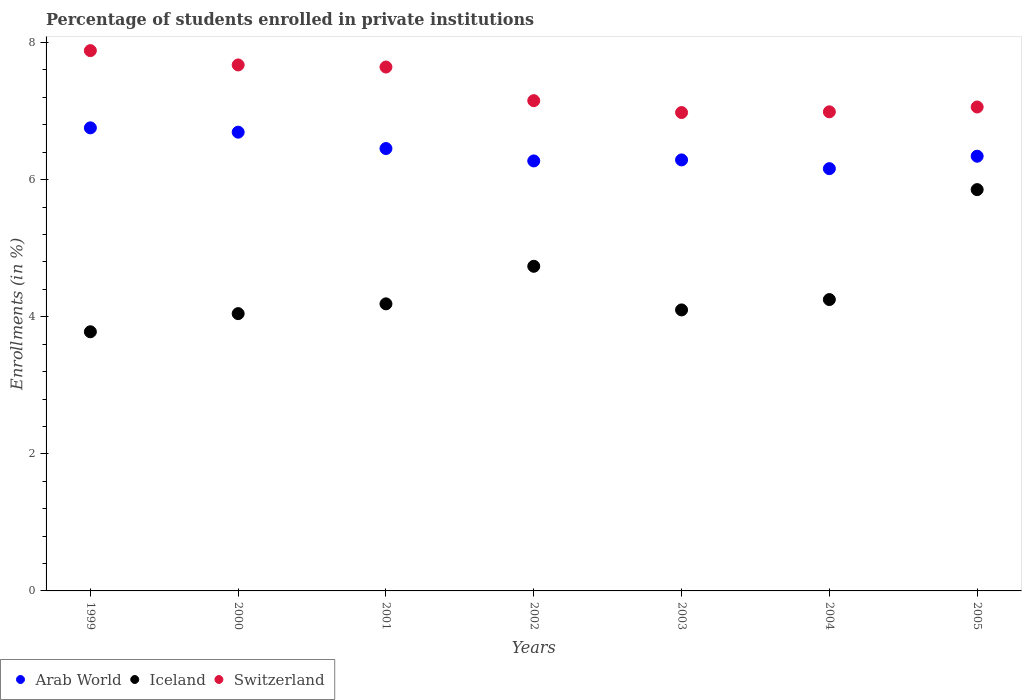How many different coloured dotlines are there?
Your answer should be compact. 3. What is the percentage of trained teachers in Switzerland in 2005?
Offer a very short reply. 7.06. Across all years, what is the maximum percentage of trained teachers in Switzerland?
Provide a succinct answer. 7.88. Across all years, what is the minimum percentage of trained teachers in Arab World?
Your answer should be compact. 6.16. In which year was the percentage of trained teachers in Switzerland maximum?
Offer a very short reply. 1999. What is the total percentage of trained teachers in Iceland in the graph?
Your response must be concise. 30.96. What is the difference between the percentage of trained teachers in Iceland in 1999 and that in 2005?
Your answer should be compact. -2.07. What is the difference between the percentage of trained teachers in Iceland in 2004 and the percentage of trained teachers in Switzerland in 2005?
Provide a short and direct response. -2.81. What is the average percentage of trained teachers in Iceland per year?
Offer a very short reply. 4.42. In the year 1999, what is the difference between the percentage of trained teachers in Switzerland and percentage of trained teachers in Iceland?
Your answer should be very brief. 4.1. What is the ratio of the percentage of trained teachers in Iceland in 1999 to that in 2000?
Make the answer very short. 0.93. Is the percentage of trained teachers in Switzerland in 1999 less than that in 2000?
Your answer should be very brief. No. What is the difference between the highest and the second highest percentage of trained teachers in Switzerland?
Make the answer very short. 0.21. What is the difference between the highest and the lowest percentage of trained teachers in Switzerland?
Provide a short and direct response. 0.9. Is the sum of the percentage of trained teachers in Switzerland in 2001 and 2002 greater than the maximum percentage of trained teachers in Arab World across all years?
Provide a succinct answer. Yes. Does the percentage of trained teachers in Switzerland monotonically increase over the years?
Your response must be concise. No. Is the percentage of trained teachers in Switzerland strictly greater than the percentage of trained teachers in Iceland over the years?
Offer a terse response. Yes. What is the difference between two consecutive major ticks on the Y-axis?
Offer a very short reply. 2. What is the title of the graph?
Make the answer very short. Percentage of students enrolled in private institutions. What is the label or title of the X-axis?
Your answer should be compact. Years. What is the label or title of the Y-axis?
Keep it short and to the point. Enrollments (in %). What is the Enrollments (in %) of Arab World in 1999?
Your response must be concise. 6.76. What is the Enrollments (in %) of Iceland in 1999?
Your answer should be compact. 3.78. What is the Enrollments (in %) in Switzerland in 1999?
Provide a succinct answer. 7.88. What is the Enrollments (in %) of Arab World in 2000?
Offer a very short reply. 6.69. What is the Enrollments (in %) of Iceland in 2000?
Provide a short and direct response. 4.05. What is the Enrollments (in %) of Switzerland in 2000?
Your answer should be very brief. 7.67. What is the Enrollments (in %) in Arab World in 2001?
Your response must be concise. 6.45. What is the Enrollments (in %) in Iceland in 2001?
Provide a succinct answer. 4.19. What is the Enrollments (in %) of Switzerland in 2001?
Your answer should be compact. 7.64. What is the Enrollments (in %) of Arab World in 2002?
Ensure brevity in your answer.  6.27. What is the Enrollments (in %) in Iceland in 2002?
Make the answer very short. 4.74. What is the Enrollments (in %) of Switzerland in 2002?
Offer a terse response. 7.15. What is the Enrollments (in %) in Arab World in 2003?
Your answer should be compact. 6.29. What is the Enrollments (in %) in Iceland in 2003?
Your answer should be very brief. 4.1. What is the Enrollments (in %) in Switzerland in 2003?
Your answer should be very brief. 6.98. What is the Enrollments (in %) in Arab World in 2004?
Offer a very short reply. 6.16. What is the Enrollments (in %) in Iceland in 2004?
Make the answer very short. 4.25. What is the Enrollments (in %) of Switzerland in 2004?
Offer a terse response. 6.99. What is the Enrollments (in %) in Arab World in 2005?
Make the answer very short. 6.34. What is the Enrollments (in %) of Iceland in 2005?
Give a very brief answer. 5.85. What is the Enrollments (in %) in Switzerland in 2005?
Offer a very short reply. 7.06. Across all years, what is the maximum Enrollments (in %) of Arab World?
Offer a terse response. 6.76. Across all years, what is the maximum Enrollments (in %) of Iceland?
Provide a succinct answer. 5.85. Across all years, what is the maximum Enrollments (in %) of Switzerland?
Provide a short and direct response. 7.88. Across all years, what is the minimum Enrollments (in %) of Arab World?
Offer a very short reply. 6.16. Across all years, what is the minimum Enrollments (in %) in Iceland?
Your answer should be compact. 3.78. Across all years, what is the minimum Enrollments (in %) of Switzerland?
Make the answer very short. 6.98. What is the total Enrollments (in %) of Arab World in the graph?
Provide a short and direct response. 44.97. What is the total Enrollments (in %) of Iceland in the graph?
Ensure brevity in your answer.  30.96. What is the total Enrollments (in %) of Switzerland in the graph?
Offer a very short reply. 51.38. What is the difference between the Enrollments (in %) in Arab World in 1999 and that in 2000?
Ensure brevity in your answer.  0.06. What is the difference between the Enrollments (in %) of Iceland in 1999 and that in 2000?
Your response must be concise. -0.26. What is the difference between the Enrollments (in %) of Switzerland in 1999 and that in 2000?
Ensure brevity in your answer.  0.21. What is the difference between the Enrollments (in %) in Arab World in 1999 and that in 2001?
Your answer should be very brief. 0.3. What is the difference between the Enrollments (in %) of Iceland in 1999 and that in 2001?
Your answer should be very brief. -0.41. What is the difference between the Enrollments (in %) in Switzerland in 1999 and that in 2001?
Keep it short and to the point. 0.24. What is the difference between the Enrollments (in %) in Arab World in 1999 and that in 2002?
Your answer should be very brief. 0.48. What is the difference between the Enrollments (in %) in Iceland in 1999 and that in 2002?
Provide a short and direct response. -0.96. What is the difference between the Enrollments (in %) of Switzerland in 1999 and that in 2002?
Offer a very short reply. 0.73. What is the difference between the Enrollments (in %) in Arab World in 1999 and that in 2003?
Provide a short and direct response. 0.47. What is the difference between the Enrollments (in %) in Iceland in 1999 and that in 2003?
Your answer should be very brief. -0.32. What is the difference between the Enrollments (in %) of Switzerland in 1999 and that in 2003?
Your answer should be compact. 0.9. What is the difference between the Enrollments (in %) in Arab World in 1999 and that in 2004?
Your response must be concise. 0.6. What is the difference between the Enrollments (in %) in Iceland in 1999 and that in 2004?
Offer a terse response. -0.47. What is the difference between the Enrollments (in %) in Switzerland in 1999 and that in 2004?
Offer a terse response. 0.89. What is the difference between the Enrollments (in %) in Arab World in 1999 and that in 2005?
Your answer should be very brief. 0.41. What is the difference between the Enrollments (in %) in Iceland in 1999 and that in 2005?
Make the answer very short. -2.07. What is the difference between the Enrollments (in %) of Switzerland in 1999 and that in 2005?
Provide a succinct answer. 0.82. What is the difference between the Enrollments (in %) of Arab World in 2000 and that in 2001?
Provide a succinct answer. 0.24. What is the difference between the Enrollments (in %) in Iceland in 2000 and that in 2001?
Offer a very short reply. -0.14. What is the difference between the Enrollments (in %) in Switzerland in 2000 and that in 2001?
Keep it short and to the point. 0.03. What is the difference between the Enrollments (in %) of Arab World in 2000 and that in 2002?
Give a very brief answer. 0.42. What is the difference between the Enrollments (in %) in Iceland in 2000 and that in 2002?
Ensure brevity in your answer.  -0.69. What is the difference between the Enrollments (in %) of Switzerland in 2000 and that in 2002?
Offer a terse response. 0.52. What is the difference between the Enrollments (in %) of Arab World in 2000 and that in 2003?
Ensure brevity in your answer.  0.4. What is the difference between the Enrollments (in %) in Iceland in 2000 and that in 2003?
Offer a terse response. -0.05. What is the difference between the Enrollments (in %) of Switzerland in 2000 and that in 2003?
Give a very brief answer. 0.69. What is the difference between the Enrollments (in %) of Arab World in 2000 and that in 2004?
Your answer should be compact. 0.53. What is the difference between the Enrollments (in %) in Iceland in 2000 and that in 2004?
Your response must be concise. -0.21. What is the difference between the Enrollments (in %) in Switzerland in 2000 and that in 2004?
Give a very brief answer. 0.68. What is the difference between the Enrollments (in %) in Arab World in 2000 and that in 2005?
Keep it short and to the point. 0.35. What is the difference between the Enrollments (in %) of Iceland in 2000 and that in 2005?
Your response must be concise. -1.81. What is the difference between the Enrollments (in %) of Switzerland in 2000 and that in 2005?
Keep it short and to the point. 0.61. What is the difference between the Enrollments (in %) of Arab World in 2001 and that in 2002?
Offer a terse response. 0.18. What is the difference between the Enrollments (in %) of Iceland in 2001 and that in 2002?
Ensure brevity in your answer.  -0.55. What is the difference between the Enrollments (in %) in Switzerland in 2001 and that in 2002?
Keep it short and to the point. 0.49. What is the difference between the Enrollments (in %) of Arab World in 2001 and that in 2003?
Provide a short and direct response. 0.17. What is the difference between the Enrollments (in %) of Iceland in 2001 and that in 2003?
Your answer should be very brief. 0.09. What is the difference between the Enrollments (in %) in Switzerland in 2001 and that in 2003?
Keep it short and to the point. 0.66. What is the difference between the Enrollments (in %) in Arab World in 2001 and that in 2004?
Provide a short and direct response. 0.29. What is the difference between the Enrollments (in %) of Iceland in 2001 and that in 2004?
Offer a terse response. -0.06. What is the difference between the Enrollments (in %) of Switzerland in 2001 and that in 2004?
Your answer should be compact. 0.65. What is the difference between the Enrollments (in %) of Arab World in 2001 and that in 2005?
Your answer should be very brief. 0.11. What is the difference between the Enrollments (in %) in Iceland in 2001 and that in 2005?
Offer a very short reply. -1.67. What is the difference between the Enrollments (in %) of Switzerland in 2001 and that in 2005?
Offer a very short reply. 0.58. What is the difference between the Enrollments (in %) in Arab World in 2002 and that in 2003?
Your response must be concise. -0.01. What is the difference between the Enrollments (in %) of Iceland in 2002 and that in 2003?
Your answer should be very brief. 0.64. What is the difference between the Enrollments (in %) in Switzerland in 2002 and that in 2003?
Make the answer very short. 0.17. What is the difference between the Enrollments (in %) in Arab World in 2002 and that in 2004?
Your response must be concise. 0.11. What is the difference between the Enrollments (in %) in Iceland in 2002 and that in 2004?
Provide a succinct answer. 0.49. What is the difference between the Enrollments (in %) of Switzerland in 2002 and that in 2004?
Offer a very short reply. 0.16. What is the difference between the Enrollments (in %) in Arab World in 2002 and that in 2005?
Offer a terse response. -0.07. What is the difference between the Enrollments (in %) of Iceland in 2002 and that in 2005?
Your answer should be very brief. -1.12. What is the difference between the Enrollments (in %) in Switzerland in 2002 and that in 2005?
Provide a succinct answer. 0.09. What is the difference between the Enrollments (in %) in Arab World in 2003 and that in 2004?
Ensure brevity in your answer.  0.13. What is the difference between the Enrollments (in %) of Iceland in 2003 and that in 2004?
Your answer should be compact. -0.15. What is the difference between the Enrollments (in %) in Switzerland in 2003 and that in 2004?
Provide a short and direct response. -0.01. What is the difference between the Enrollments (in %) in Arab World in 2003 and that in 2005?
Ensure brevity in your answer.  -0.05. What is the difference between the Enrollments (in %) of Iceland in 2003 and that in 2005?
Keep it short and to the point. -1.75. What is the difference between the Enrollments (in %) of Switzerland in 2003 and that in 2005?
Ensure brevity in your answer.  -0.08. What is the difference between the Enrollments (in %) in Arab World in 2004 and that in 2005?
Keep it short and to the point. -0.18. What is the difference between the Enrollments (in %) in Iceland in 2004 and that in 2005?
Provide a succinct answer. -1.6. What is the difference between the Enrollments (in %) of Switzerland in 2004 and that in 2005?
Keep it short and to the point. -0.07. What is the difference between the Enrollments (in %) of Arab World in 1999 and the Enrollments (in %) of Iceland in 2000?
Your answer should be compact. 2.71. What is the difference between the Enrollments (in %) in Arab World in 1999 and the Enrollments (in %) in Switzerland in 2000?
Your answer should be compact. -0.92. What is the difference between the Enrollments (in %) in Iceland in 1999 and the Enrollments (in %) in Switzerland in 2000?
Offer a very short reply. -3.89. What is the difference between the Enrollments (in %) in Arab World in 1999 and the Enrollments (in %) in Iceland in 2001?
Your answer should be very brief. 2.57. What is the difference between the Enrollments (in %) of Arab World in 1999 and the Enrollments (in %) of Switzerland in 2001?
Offer a terse response. -0.89. What is the difference between the Enrollments (in %) of Iceland in 1999 and the Enrollments (in %) of Switzerland in 2001?
Provide a succinct answer. -3.86. What is the difference between the Enrollments (in %) of Arab World in 1999 and the Enrollments (in %) of Iceland in 2002?
Your response must be concise. 2.02. What is the difference between the Enrollments (in %) in Arab World in 1999 and the Enrollments (in %) in Switzerland in 2002?
Offer a terse response. -0.4. What is the difference between the Enrollments (in %) in Iceland in 1999 and the Enrollments (in %) in Switzerland in 2002?
Your answer should be very brief. -3.37. What is the difference between the Enrollments (in %) of Arab World in 1999 and the Enrollments (in %) of Iceland in 2003?
Your response must be concise. 2.66. What is the difference between the Enrollments (in %) in Arab World in 1999 and the Enrollments (in %) in Switzerland in 2003?
Provide a succinct answer. -0.22. What is the difference between the Enrollments (in %) in Iceland in 1999 and the Enrollments (in %) in Switzerland in 2003?
Offer a terse response. -3.2. What is the difference between the Enrollments (in %) of Arab World in 1999 and the Enrollments (in %) of Iceland in 2004?
Your answer should be very brief. 2.51. What is the difference between the Enrollments (in %) in Arab World in 1999 and the Enrollments (in %) in Switzerland in 2004?
Ensure brevity in your answer.  -0.23. What is the difference between the Enrollments (in %) in Iceland in 1999 and the Enrollments (in %) in Switzerland in 2004?
Provide a short and direct response. -3.21. What is the difference between the Enrollments (in %) of Arab World in 1999 and the Enrollments (in %) of Iceland in 2005?
Keep it short and to the point. 0.9. What is the difference between the Enrollments (in %) of Arab World in 1999 and the Enrollments (in %) of Switzerland in 2005?
Offer a terse response. -0.3. What is the difference between the Enrollments (in %) in Iceland in 1999 and the Enrollments (in %) in Switzerland in 2005?
Give a very brief answer. -3.28. What is the difference between the Enrollments (in %) in Arab World in 2000 and the Enrollments (in %) in Iceland in 2001?
Your response must be concise. 2.5. What is the difference between the Enrollments (in %) in Arab World in 2000 and the Enrollments (in %) in Switzerland in 2001?
Offer a very short reply. -0.95. What is the difference between the Enrollments (in %) in Iceland in 2000 and the Enrollments (in %) in Switzerland in 2001?
Your response must be concise. -3.6. What is the difference between the Enrollments (in %) of Arab World in 2000 and the Enrollments (in %) of Iceland in 2002?
Give a very brief answer. 1.96. What is the difference between the Enrollments (in %) in Arab World in 2000 and the Enrollments (in %) in Switzerland in 2002?
Ensure brevity in your answer.  -0.46. What is the difference between the Enrollments (in %) in Iceland in 2000 and the Enrollments (in %) in Switzerland in 2002?
Your response must be concise. -3.11. What is the difference between the Enrollments (in %) of Arab World in 2000 and the Enrollments (in %) of Iceland in 2003?
Ensure brevity in your answer.  2.59. What is the difference between the Enrollments (in %) in Arab World in 2000 and the Enrollments (in %) in Switzerland in 2003?
Ensure brevity in your answer.  -0.29. What is the difference between the Enrollments (in %) in Iceland in 2000 and the Enrollments (in %) in Switzerland in 2003?
Your response must be concise. -2.93. What is the difference between the Enrollments (in %) of Arab World in 2000 and the Enrollments (in %) of Iceland in 2004?
Keep it short and to the point. 2.44. What is the difference between the Enrollments (in %) in Arab World in 2000 and the Enrollments (in %) in Switzerland in 2004?
Your answer should be very brief. -0.3. What is the difference between the Enrollments (in %) of Iceland in 2000 and the Enrollments (in %) of Switzerland in 2004?
Provide a succinct answer. -2.94. What is the difference between the Enrollments (in %) in Arab World in 2000 and the Enrollments (in %) in Iceland in 2005?
Offer a terse response. 0.84. What is the difference between the Enrollments (in %) of Arab World in 2000 and the Enrollments (in %) of Switzerland in 2005?
Ensure brevity in your answer.  -0.37. What is the difference between the Enrollments (in %) of Iceland in 2000 and the Enrollments (in %) of Switzerland in 2005?
Your answer should be compact. -3.01. What is the difference between the Enrollments (in %) of Arab World in 2001 and the Enrollments (in %) of Iceland in 2002?
Your answer should be very brief. 1.72. What is the difference between the Enrollments (in %) of Arab World in 2001 and the Enrollments (in %) of Switzerland in 2002?
Give a very brief answer. -0.7. What is the difference between the Enrollments (in %) in Iceland in 2001 and the Enrollments (in %) in Switzerland in 2002?
Provide a short and direct response. -2.96. What is the difference between the Enrollments (in %) of Arab World in 2001 and the Enrollments (in %) of Iceland in 2003?
Offer a terse response. 2.35. What is the difference between the Enrollments (in %) in Arab World in 2001 and the Enrollments (in %) in Switzerland in 2003?
Provide a succinct answer. -0.53. What is the difference between the Enrollments (in %) in Iceland in 2001 and the Enrollments (in %) in Switzerland in 2003?
Ensure brevity in your answer.  -2.79. What is the difference between the Enrollments (in %) of Arab World in 2001 and the Enrollments (in %) of Iceland in 2004?
Ensure brevity in your answer.  2.2. What is the difference between the Enrollments (in %) of Arab World in 2001 and the Enrollments (in %) of Switzerland in 2004?
Your response must be concise. -0.54. What is the difference between the Enrollments (in %) of Iceland in 2001 and the Enrollments (in %) of Switzerland in 2004?
Ensure brevity in your answer.  -2.8. What is the difference between the Enrollments (in %) of Arab World in 2001 and the Enrollments (in %) of Iceland in 2005?
Provide a succinct answer. 0.6. What is the difference between the Enrollments (in %) of Arab World in 2001 and the Enrollments (in %) of Switzerland in 2005?
Make the answer very short. -0.61. What is the difference between the Enrollments (in %) in Iceland in 2001 and the Enrollments (in %) in Switzerland in 2005?
Give a very brief answer. -2.87. What is the difference between the Enrollments (in %) of Arab World in 2002 and the Enrollments (in %) of Iceland in 2003?
Give a very brief answer. 2.17. What is the difference between the Enrollments (in %) of Arab World in 2002 and the Enrollments (in %) of Switzerland in 2003?
Offer a very short reply. -0.71. What is the difference between the Enrollments (in %) in Iceland in 2002 and the Enrollments (in %) in Switzerland in 2003?
Your response must be concise. -2.24. What is the difference between the Enrollments (in %) in Arab World in 2002 and the Enrollments (in %) in Iceland in 2004?
Provide a short and direct response. 2.02. What is the difference between the Enrollments (in %) in Arab World in 2002 and the Enrollments (in %) in Switzerland in 2004?
Your answer should be very brief. -0.72. What is the difference between the Enrollments (in %) in Iceland in 2002 and the Enrollments (in %) in Switzerland in 2004?
Offer a terse response. -2.25. What is the difference between the Enrollments (in %) in Arab World in 2002 and the Enrollments (in %) in Iceland in 2005?
Make the answer very short. 0.42. What is the difference between the Enrollments (in %) in Arab World in 2002 and the Enrollments (in %) in Switzerland in 2005?
Your answer should be very brief. -0.79. What is the difference between the Enrollments (in %) of Iceland in 2002 and the Enrollments (in %) of Switzerland in 2005?
Make the answer very short. -2.32. What is the difference between the Enrollments (in %) of Arab World in 2003 and the Enrollments (in %) of Iceland in 2004?
Your response must be concise. 2.04. What is the difference between the Enrollments (in %) of Arab World in 2003 and the Enrollments (in %) of Switzerland in 2004?
Provide a succinct answer. -0.7. What is the difference between the Enrollments (in %) in Iceland in 2003 and the Enrollments (in %) in Switzerland in 2004?
Offer a very short reply. -2.89. What is the difference between the Enrollments (in %) of Arab World in 2003 and the Enrollments (in %) of Iceland in 2005?
Make the answer very short. 0.43. What is the difference between the Enrollments (in %) in Arab World in 2003 and the Enrollments (in %) in Switzerland in 2005?
Provide a short and direct response. -0.77. What is the difference between the Enrollments (in %) in Iceland in 2003 and the Enrollments (in %) in Switzerland in 2005?
Keep it short and to the point. -2.96. What is the difference between the Enrollments (in %) of Arab World in 2004 and the Enrollments (in %) of Iceland in 2005?
Your response must be concise. 0.31. What is the difference between the Enrollments (in %) of Arab World in 2004 and the Enrollments (in %) of Switzerland in 2005?
Your answer should be compact. -0.9. What is the difference between the Enrollments (in %) of Iceland in 2004 and the Enrollments (in %) of Switzerland in 2005?
Keep it short and to the point. -2.81. What is the average Enrollments (in %) of Arab World per year?
Make the answer very short. 6.42. What is the average Enrollments (in %) in Iceland per year?
Give a very brief answer. 4.42. What is the average Enrollments (in %) in Switzerland per year?
Provide a short and direct response. 7.34. In the year 1999, what is the difference between the Enrollments (in %) of Arab World and Enrollments (in %) of Iceland?
Keep it short and to the point. 2.98. In the year 1999, what is the difference between the Enrollments (in %) in Arab World and Enrollments (in %) in Switzerland?
Your response must be concise. -1.13. In the year 1999, what is the difference between the Enrollments (in %) in Iceland and Enrollments (in %) in Switzerland?
Your response must be concise. -4.1. In the year 2000, what is the difference between the Enrollments (in %) in Arab World and Enrollments (in %) in Iceland?
Give a very brief answer. 2.65. In the year 2000, what is the difference between the Enrollments (in %) in Arab World and Enrollments (in %) in Switzerland?
Offer a terse response. -0.98. In the year 2000, what is the difference between the Enrollments (in %) of Iceland and Enrollments (in %) of Switzerland?
Ensure brevity in your answer.  -3.63. In the year 2001, what is the difference between the Enrollments (in %) of Arab World and Enrollments (in %) of Iceland?
Make the answer very short. 2.27. In the year 2001, what is the difference between the Enrollments (in %) of Arab World and Enrollments (in %) of Switzerland?
Make the answer very short. -1.19. In the year 2001, what is the difference between the Enrollments (in %) of Iceland and Enrollments (in %) of Switzerland?
Ensure brevity in your answer.  -3.46. In the year 2002, what is the difference between the Enrollments (in %) in Arab World and Enrollments (in %) in Iceland?
Make the answer very short. 1.54. In the year 2002, what is the difference between the Enrollments (in %) in Arab World and Enrollments (in %) in Switzerland?
Make the answer very short. -0.88. In the year 2002, what is the difference between the Enrollments (in %) of Iceland and Enrollments (in %) of Switzerland?
Provide a short and direct response. -2.42. In the year 2003, what is the difference between the Enrollments (in %) in Arab World and Enrollments (in %) in Iceland?
Ensure brevity in your answer.  2.19. In the year 2003, what is the difference between the Enrollments (in %) of Arab World and Enrollments (in %) of Switzerland?
Your answer should be compact. -0.69. In the year 2003, what is the difference between the Enrollments (in %) of Iceland and Enrollments (in %) of Switzerland?
Offer a terse response. -2.88. In the year 2004, what is the difference between the Enrollments (in %) of Arab World and Enrollments (in %) of Iceland?
Your answer should be very brief. 1.91. In the year 2004, what is the difference between the Enrollments (in %) in Arab World and Enrollments (in %) in Switzerland?
Ensure brevity in your answer.  -0.83. In the year 2004, what is the difference between the Enrollments (in %) of Iceland and Enrollments (in %) of Switzerland?
Make the answer very short. -2.74. In the year 2005, what is the difference between the Enrollments (in %) of Arab World and Enrollments (in %) of Iceland?
Ensure brevity in your answer.  0.49. In the year 2005, what is the difference between the Enrollments (in %) of Arab World and Enrollments (in %) of Switzerland?
Provide a succinct answer. -0.72. In the year 2005, what is the difference between the Enrollments (in %) of Iceland and Enrollments (in %) of Switzerland?
Your response must be concise. -1.21. What is the ratio of the Enrollments (in %) in Arab World in 1999 to that in 2000?
Ensure brevity in your answer.  1.01. What is the ratio of the Enrollments (in %) of Iceland in 1999 to that in 2000?
Provide a succinct answer. 0.93. What is the ratio of the Enrollments (in %) in Switzerland in 1999 to that in 2000?
Your response must be concise. 1.03. What is the ratio of the Enrollments (in %) in Arab World in 1999 to that in 2001?
Offer a very short reply. 1.05. What is the ratio of the Enrollments (in %) of Iceland in 1999 to that in 2001?
Give a very brief answer. 0.9. What is the ratio of the Enrollments (in %) in Switzerland in 1999 to that in 2001?
Give a very brief answer. 1.03. What is the ratio of the Enrollments (in %) of Arab World in 1999 to that in 2002?
Make the answer very short. 1.08. What is the ratio of the Enrollments (in %) of Iceland in 1999 to that in 2002?
Your answer should be compact. 0.8. What is the ratio of the Enrollments (in %) in Switzerland in 1999 to that in 2002?
Provide a succinct answer. 1.1. What is the ratio of the Enrollments (in %) in Arab World in 1999 to that in 2003?
Provide a short and direct response. 1.07. What is the ratio of the Enrollments (in %) in Iceland in 1999 to that in 2003?
Provide a short and direct response. 0.92. What is the ratio of the Enrollments (in %) in Switzerland in 1999 to that in 2003?
Offer a very short reply. 1.13. What is the ratio of the Enrollments (in %) of Arab World in 1999 to that in 2004?
Your answer should be very brief. 1.1. What is the ratio of the Enrollments (in %) of Iceland in 1999 to that in 2004?
Provide a succinct answer. 0.89. What is the ratio of the Enrollments (in %) in Switzerland in 1999 to that in 2004?
Provide a short and direct response. 1.13. What is the ratio of the Enrollments (in %) in Arab World in 1999 to that in 2005?
Give a very brief answer. 1.07. What is the ratio of the Enrollments (in %) in Iceland in 1999 to that in 2005?
Your answer should be very brief. 0.65. What is the ratio of the Enrollments (in %) of Switzerland in 1999 to that in 2005?
Make the answer very short. 1.12. What is the ratio of the Enrollments (in %) of Arab World in 2000 to that in 2001?
Provide a succinct answer. 1.04. What is the ratio of the Enrollments (in %) in Iceland in 2000 to that in 2001?
Give a very brief answer. 0.97. What is the ratio of the Enrollments (in %) of Switzerland in 2000 to that in 2001?
Offer a terse response. 1. What is the ratio of the Enrollments (in %) of Arab World in 2000 to that in 2002?
Your answer should be very brief. 1.07. What is the ratio of the Enrollments (in %) of Iceland in 2000 to that in 2002?
Offer a terse response. 0.85. What is the ratio of the Enrollments (in %) in Switzerland in 2000 to that in 2002?
Provide a succinct answer. 1.07. What is the ratio of the Enrollments (in %) in Arab World in 2000 to that in 2003?
Give a very brief answer. 1.06. What is the ratio of the Enrollments (in %) of Switzerland in 2000 to that in 2003?
Make the answer very short. 1.1. What is the ratio of the Enrollments (in %) in Arab World in 2000 to that in 2004?
Ensure brevity in your answer.  1.09. What is the ratio of the Enrollments (in %) of Iceland in 2000 to that in 2004?
Your response must be concise. 0.95. What is the ratio of the Enrollments (in %) in Switzerland in 2000 to that in 2004?
Provide a short and direct response. 1.1. What is the ratio of the Enrollments (in %) in Arab World in 2000 to that in 2005?
Your response must be concise. 1.06. What is the ratio of the Enrollments (in %) of Iceland in 2000 to that in 2005?
Your answer should be very brief. 0.69. What is the ratio of the Enrollments (in %) in Switzerland in 2000 to that in 2005?
Give a very brief answer. 1.09. What is the ratio of the Enrollments (in %) of Arab World in 2001 to that in 2002?
Provide a short and direct response. 1.03. What is the ratio of the Enrollments (in %) of Iceland in 2001 to that in 2002?
Provide a short and direct response. 0.88. What is the ratio of the Enrollments (in %) in Switzerland in 2001 to that in 2002?
Your response must be concise. 1.07. What is the ratio of the Enrollments (in %) of Arab World in 2001 to that in 2003?
Your response must be concise. 1.03. What is the ratio of the Enrollments (in %) of Iceland in 2001 to that in 2003?
Your answer should be compact. 1.02. What is the ratio of the Enrollments (in %) of Switzerland in 2001 to that in 2003?
Offer a terse response. 1.1. What is the ratio of the Enrollments (in %) in Arab World in 2001 to that in 2004?
Offer a terse response. 1.05. What is the ratio of the Enrollments (in %) of Iceland in 2001 to that in 2004?
Ensure brevity in your answer.  0.99. What is the ratio of the Enrollments (in %) in Switzerland in 2001 to that in 2004?
Offer a terse response. 1.09. What is the ratio of the Enrollments (in %) in Arab World in 2001 to that in 2005?
Make the answer very short. 1.02. What is the ratio of the Enrollments (in %) of Iceland in 2001 to that in 2005?
Your answer should be compact. 0.72. What is the ratio of the Enrollments (in %) of Switzerland in 2001 to that in 2005?
Make the answer very short. 1.08. What is the ratio of the Enrollments (in %) in Iceland in 2002 to that in 2003?
Provide a succinct answer. 1.16. What is the ratio of the Enrollments (in %) of Switzerland in 2002 to that in 2003?
Your response must be concise. 1.02. What is the ratio of the Enrollments (in %) of Arab World in 2002 to that in 2004?
Provide a short and direct response. 1.02. What is the ratio of the Enrollments (in %) of Iceland in 2002 to that in 2004?
Make the answer very short. 1.11. What is the ratio of the Enrollments (in %) of Switzerland in 2002 to that in 2004?
Keep it short and to the point. 1.02. What is the ratio of the Enrollments (in %) in Iceland in 2002 to that in 2005?
Ensure brevity in your answer.  0.81. What is the ratio of the Enrollments (in %) in Switzerland in 2002 to that in 2005?
Ensure brevity in your answer.  1.01. What is the ratio of the Enrollments (in %) in Arab World in 2003 to that in 2004?
Give a very brief answer. 1.02. What is the ratio of the Enrollments (in %) of Iceland in 2003 to that in 2004?
Ensure brevity in your answer.  0.96. What is the ratio of the Enrollments (in %) of Iceland in 2003 to that in 2005?
Make the answer very short. 0.7. What is the ratio of the Enrollments (in %) in Arab World in 2004 to that in 2005?
Make the answer very short. 0.97. What is the ratio of the Enrollments (in %) in Iceland in 2004 to that in 2005?
Offer a terse response. 0.73. What is the difference between the highest and the second highest Enrollments (in %) of Arab World?
Offer a terse response. 0.06. What is the difference between the highest and the second highest Enrollments (in %) of Iceland?
Provide a succinct answer. 1.12. What is the difference between the highest and the second highest Enrollments (in %) in Switzerland?
Ensure brevity in your answer.  0.21. What is the difference between the highest and the lowest Enrollments (in %) in Arab World?
Give a very brief answer. 0.6. What is the difference between the highest and the lowest Enrollments (in %) of Iceland?
Your answer should be very brief. 2.07. What is the difference between the highest and the lowest Enrollments (in %) in Switzerland?
Provide a succinct answer. 0.9. 